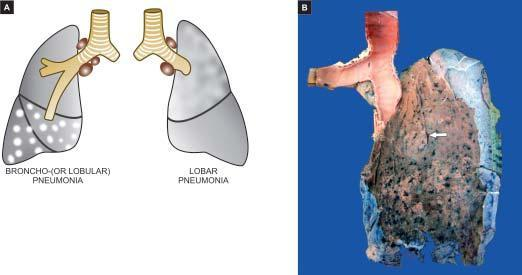what does the pleural surface of the specimen of the lung show?
Answer the question using a single word or phrase. Serofibrinous exudate 